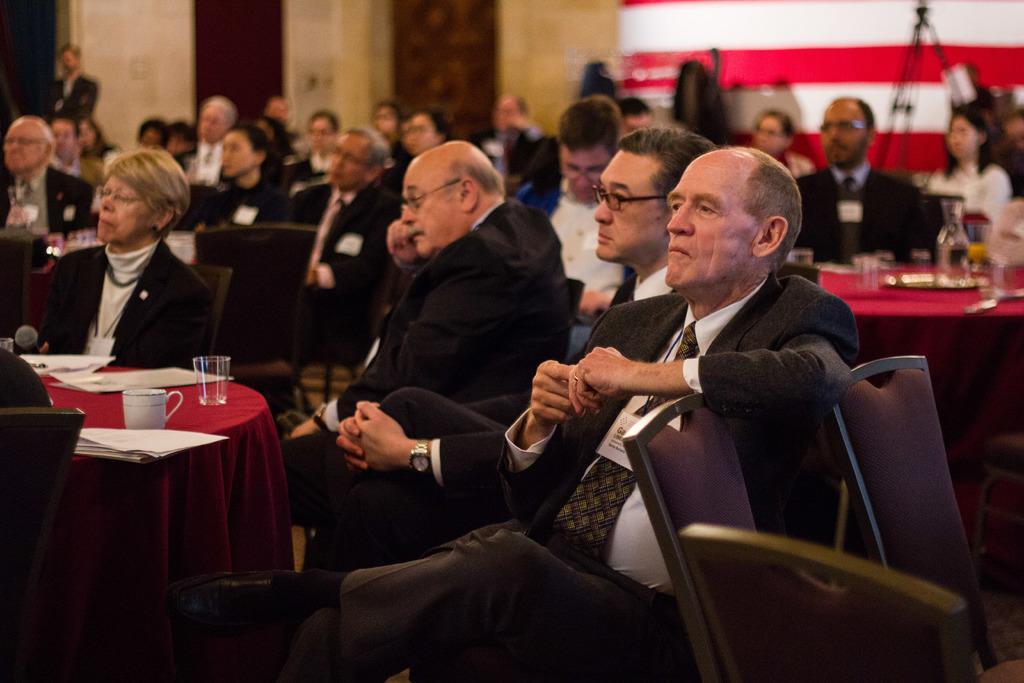Please provide a concise description of this image. In this image we can see these people are sitting on the chairs near the tables where glasses, cups and papers are kept. The background of the image is blurred, where we can see the tripod stand and the wall. 